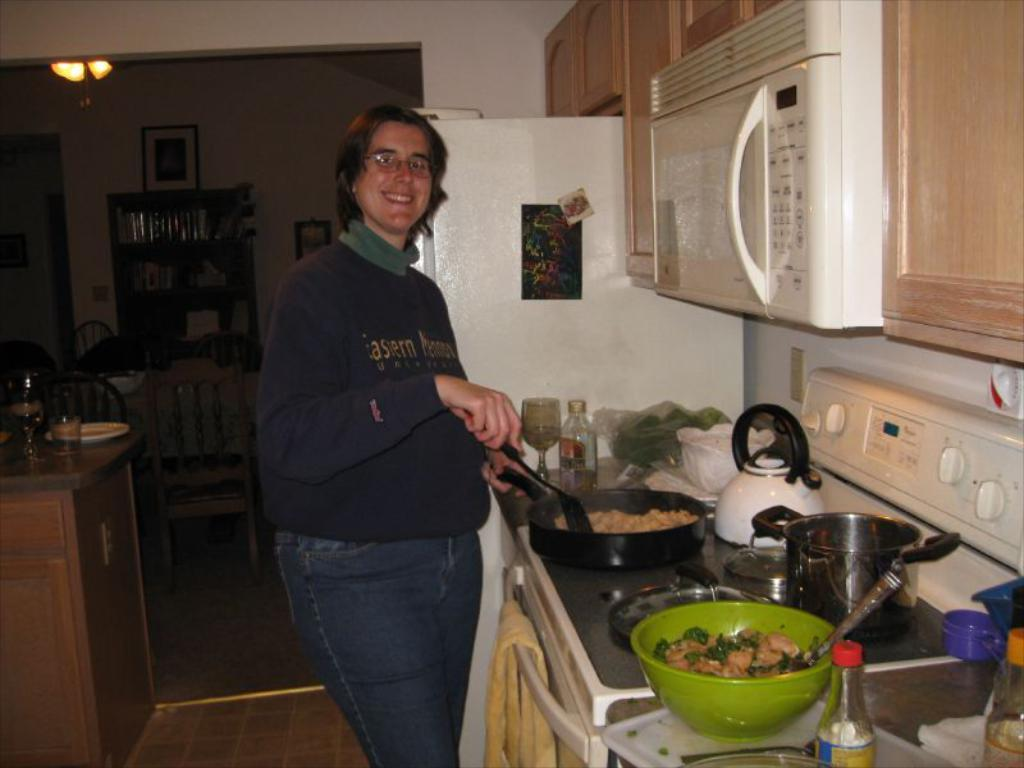<image>
Share a concise interpretation of the image provided. A woman with a shirt that has the word eastern on it standing at a stove in a kitchen 